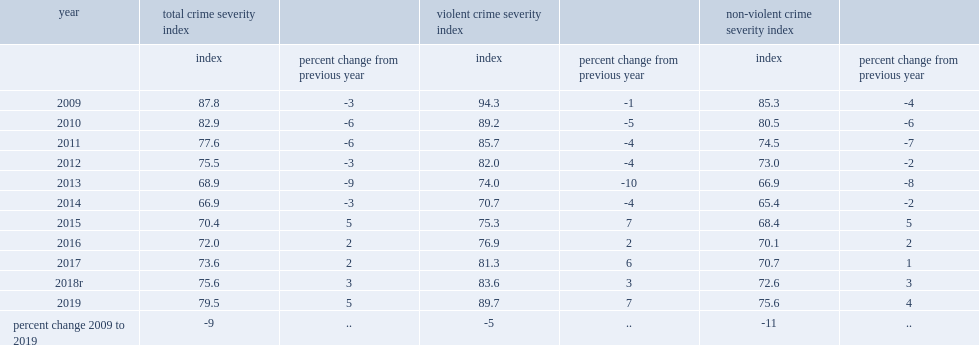Between 2018 and 2019, how mnay percent did canada's non-violent crime severity index (nvcsi), which includes property and other non-violent criminal code offences, drug crime, other federal statutes and criminal code traffic offences rise? 4.0. 